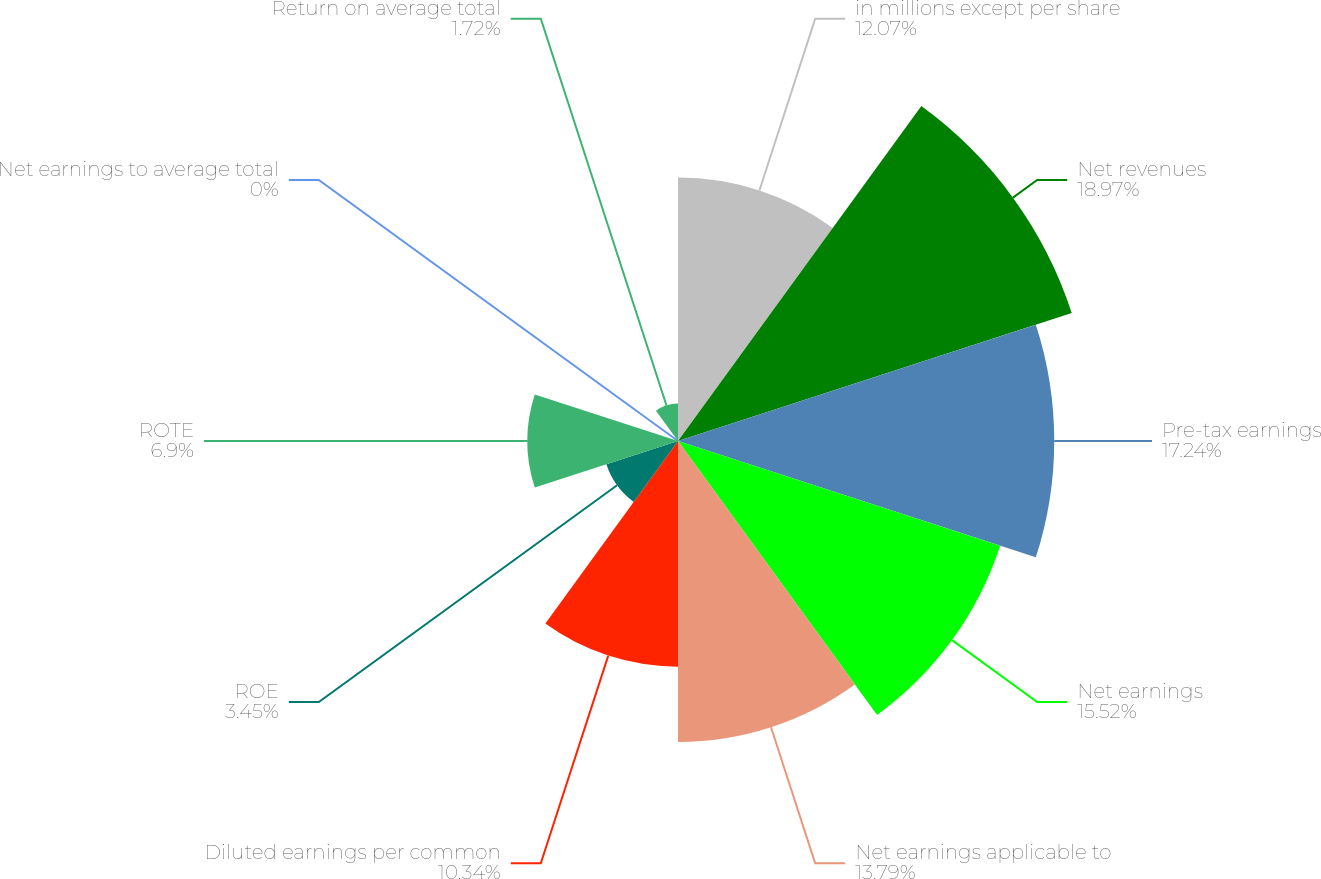Convert chart to OTSL. <chart><loc_0><loc_0><loc_500><loc_500><pie_chart><fcel>in millions except per share<fcel>Net revenues<fcel>Pre-tax earnings<fcel>Net earnings<fcel>Net earnings applicable to<fcel>Diluted earnings per common<fcel>ROE<fcel>ROTE<fcel>Net earnings to average total<fcel>Return on average total<nl><fcel>12.07%<fcel>18.97%<fcel>17.24%<fcel>15.52%<fcel>13.79%<fcel>10.34%<fcel>3.45%<fcel>6.9%<fcel>0.0%<fcel>1.72%<nl></chart> 